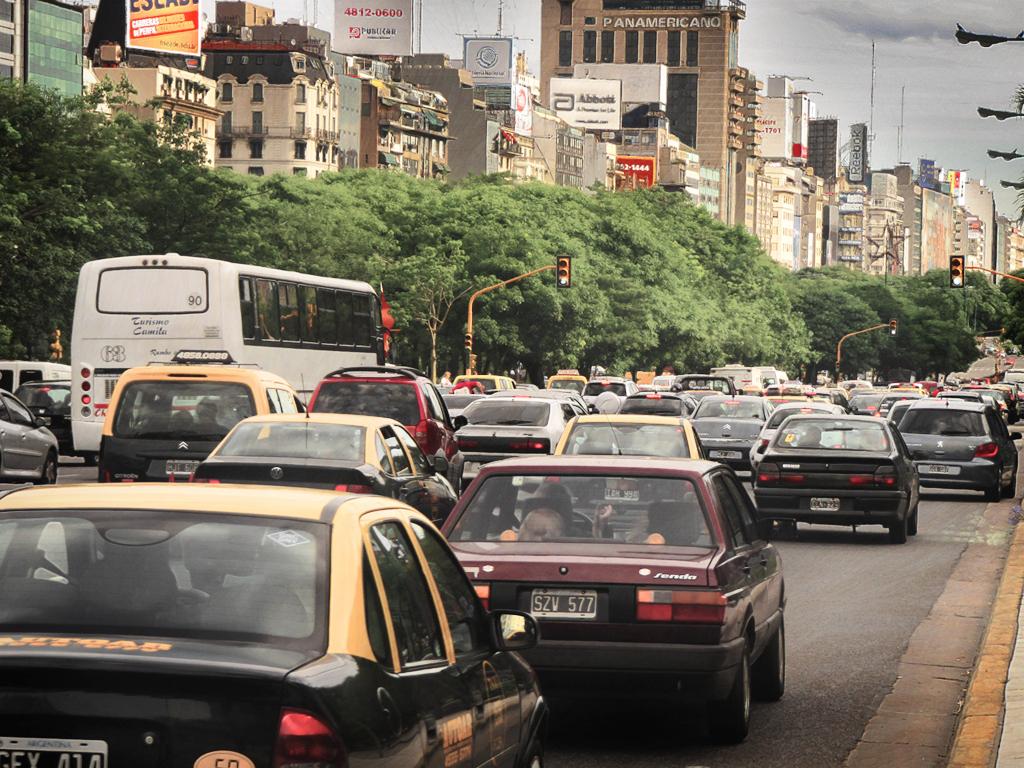What is the number on the white bus?
Keep it short and to the point. 90. 